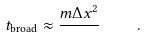Convert formula to latex. <formula><loc_0><loc_0><loc_500><loc_500>t _ { \text {broad} } \approx \frac { m \Delta x ^ { 2 } } { } \quad .</formula> 